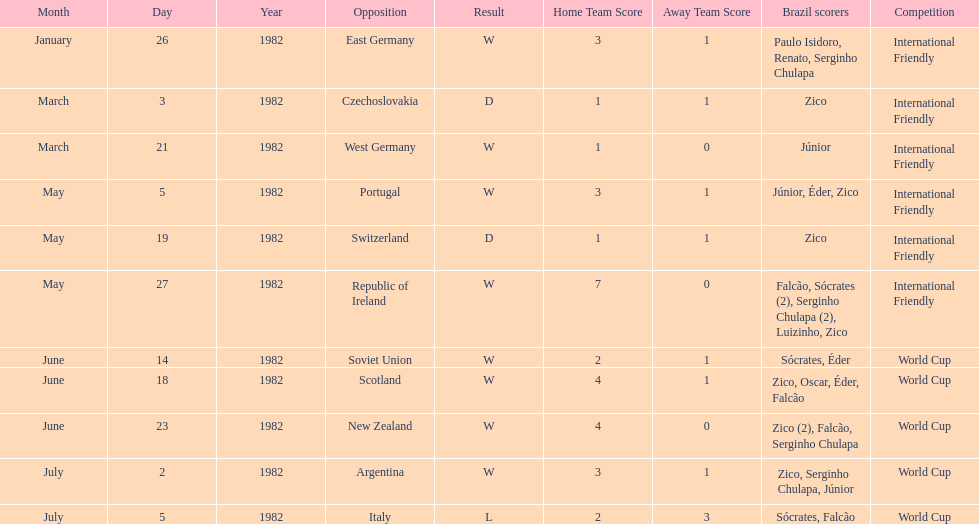What is the number of games won by brazil during the month of march 1982? 1. 